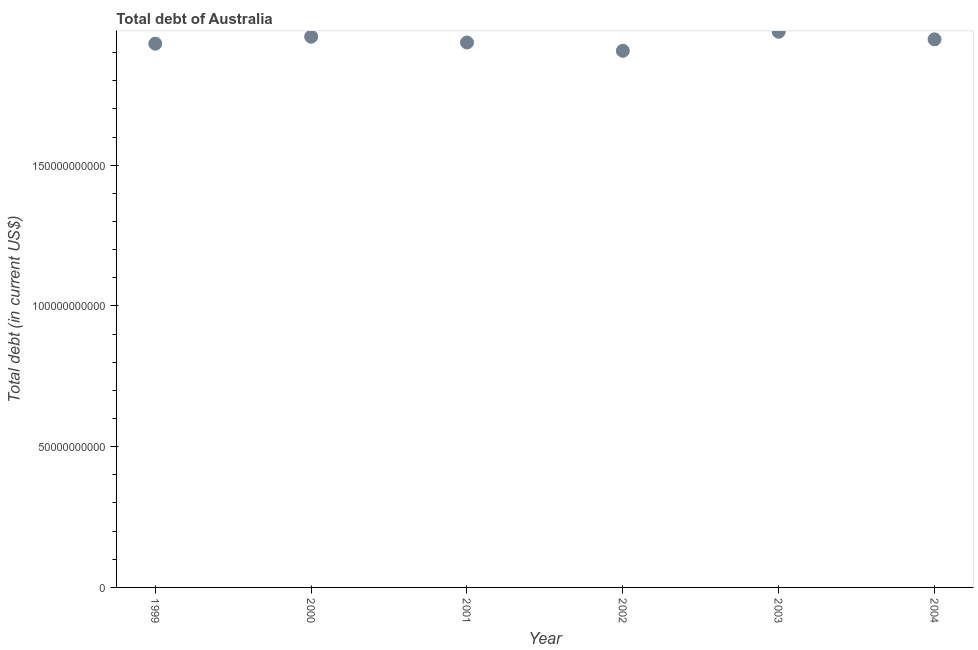What is the total debt in 2004?
Offer a very short reply. 1.95e+11. Across all years, what is the maximum total debt?
Offer a very short reply. 1.97e+11. Across all years, what is the minimum total debt?
Your answer should be compact. 1.91e+11. In which year was the total debt maximum?
Offer a terse response. 2003. What is the sum of the total debt?
Ensure brevity in your answer.  1.17e+12. What is the difference between the total debt in 2002 and 2003?
Provide a short and direct response. -6.76e+09. What is the average total debt per year?
Make the answer very short. 1.94e+11. What is the median total debt?
Offer a very short reply. 1.94e+11. In how many years, is the total debt greater than 140000000000 US$?
Ensure brevity in your answer.  6. Do a majority of the years between 2003 and 2004 (inclusive) have total debt greater than 170000000000 US$?
Make the answer very short. Yes. What is the ratio of the total debt in 1999 to that in 2003?
Your answer should be very brief. 0.98. Is the difference between the total debt in 2000 and 2003 greater than the difference between any two years?
Your answer should be very brief. No. What is the difference between the highest and the second highest total debt?
Provide a short and direct response. 1.76e+09. Is the sum of the total debt in 1999 and 2002 greater than the maximum total debt across all years?
Provide a short and direct response. Yes. What is the difference between the highest and the lowest total debt?
Your response must be concise. 6.76e+09. Does the total debt monotonically increase over the years?
Your response must be concise. No. How many dotlines are there?
Give a very brief answer. 1. Does the graph contain any zero values?
Your answer should be very brief. No. Does the graph contain grids?
Provide a succinct answer. No. What is the title of the graph?
Your answer should be compact. Total debt of Australia. What is the label or title of the Y-axis?
Give a very brief answer. Total debt (in current US$). What is the Total debt (in current US$) in 1999?
Your answer should be very brief. 1.93e+11. What is the Total debt (in current US$) in 2000?
Your response must be concise. 1.96e+11. What is the Total debt (in current US$) in 2001?
Make the answer very short. 1.94e+11. What is the Total debt (in current US$) in 2002?
Give a very brief answer. 1.91e+11. What is the Total debt (in current US$) in 2003?
Your answer should be compact. 1.97e+11. What is the Total debt (in current US$) in 2004?
Offer a terse response. 1.95e+11. What is the difference between the Total debt (in current US$) in 1999 and 2000?
Give a very brief answer. -2.47e+09. What is the difference between the Total debt (in current US$) in 1999 and 2001?
Your response must be concise. -4.10e+08. What is the difference between the Total debt (in current US$) in 1999 and 2002?
Your answer should be compact. 2.54e+09. What is the difference between the Total debt (in current US$) in 1999 and 2003?
Give a very brief answer. -4.22e+09. What is the difference between the Total debt (in current US$) in 1999 and 2004?
Ensure brevity in your answer.  -1.54e+09. What is the difference between the Total debt (in current US$) in 2000 and 2001?
Offer a very short reply. 2.06e+09. What is the difference between the Total debt (in current US$) in 2000 and 2002?
Provide a short and direct response. 5.01e+09. What is the difference between the Total debt (in current US$) in 2000 and 2003?
Offer a very short reply. -1.76e+09. What is the difference between the Total debt (in current US$) in 2000 and 2004?
Offer a very short reply. 9.31e+08. What is the difference between the Total debt (in current US$) in 2001 and 2002?
Your response must be concise. 2.95e+09. What is the difference between the Total debt (in current US$) in 2001 and 2003?
Keep it short and to the point. -3.81e+09. What is the difference between the Total debt (in current US$) in 2001 and 2004?
Offer a very short reply. -1.13e+09. What is the difference between the Total debt (in current US$) in 2002 and 2003?
Your response must be concise. -6.76e+09. What is the difference between the Total debt (in current US$) in 2002 and 2004?
Provide a short and direct response. -4.08e+09. What is the difference between the Total debt (in current US$) in 2003 and 2004?
Your response must be concise. 2.69e+09. What is the ratio of the Total debt (in current US$) in 1999 to that in 2000?
Make the answer very short. 0.99. What is the ratio of the Total debt (in current US$) in 1999 to that in 2001?
Make the answer very short. 1. What is the ratio of the Total debt (in current US$) in 1999 to that in 2002?
Give a very brief answer. 1.01. What is the ratio of the Total debt (in current US$) in 2000 to that in 2001?
Your answer should be compact. 1.01. What is the ratio of the Total debt (in current US$) in 2000 to that in 2002?
Give a very brief answer. 1.03. What is the ratio of the Total debt (in current US$) in 2000 to that in 2004?
Give a very brief answer. 1. What is the ratio of the Total debt (in current US$) in 2002 to that in 2003?
Ensure brevity in your answer.  0.97. What is the ratio of the Total debt (in current US$) in 2002 to that in 2004?
Offer a very short reply. 0.98. What is the ratio of the Total debt (in current US$) in 2003 to that in 2004?
Offer a terse response. 1.01. 